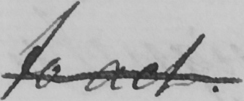Can you tell me what this handwritten text says? To act 